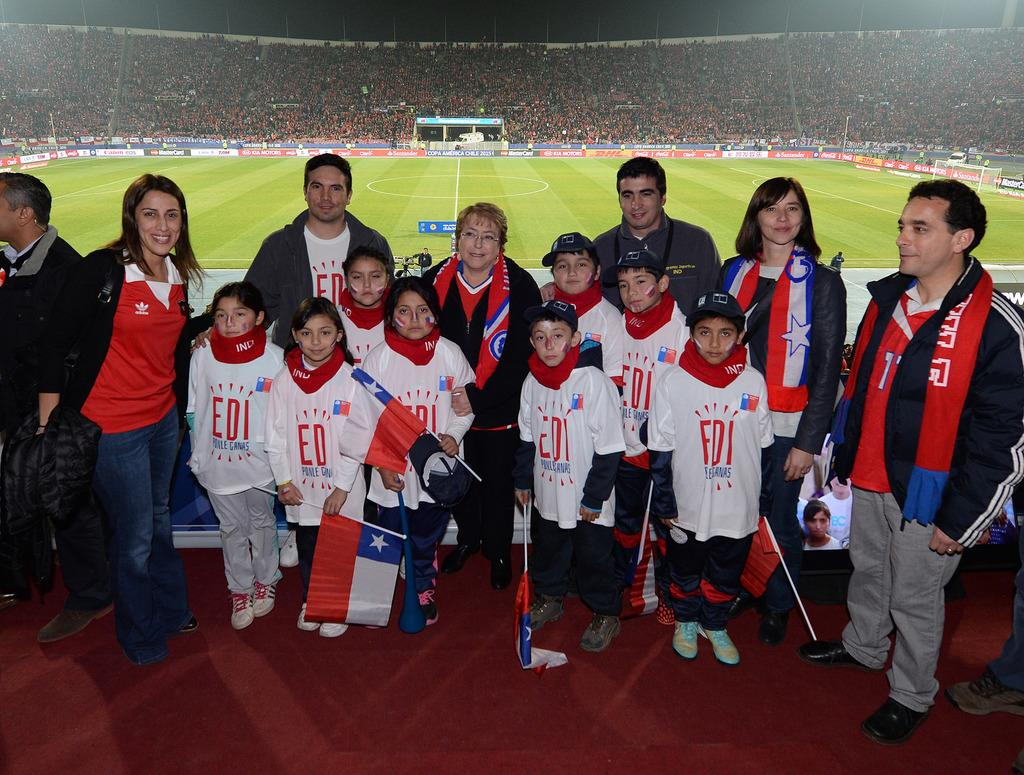Provide a one-sentence caption for the provided image. Group of children wearing "EDI" shirts posing for a picture. 